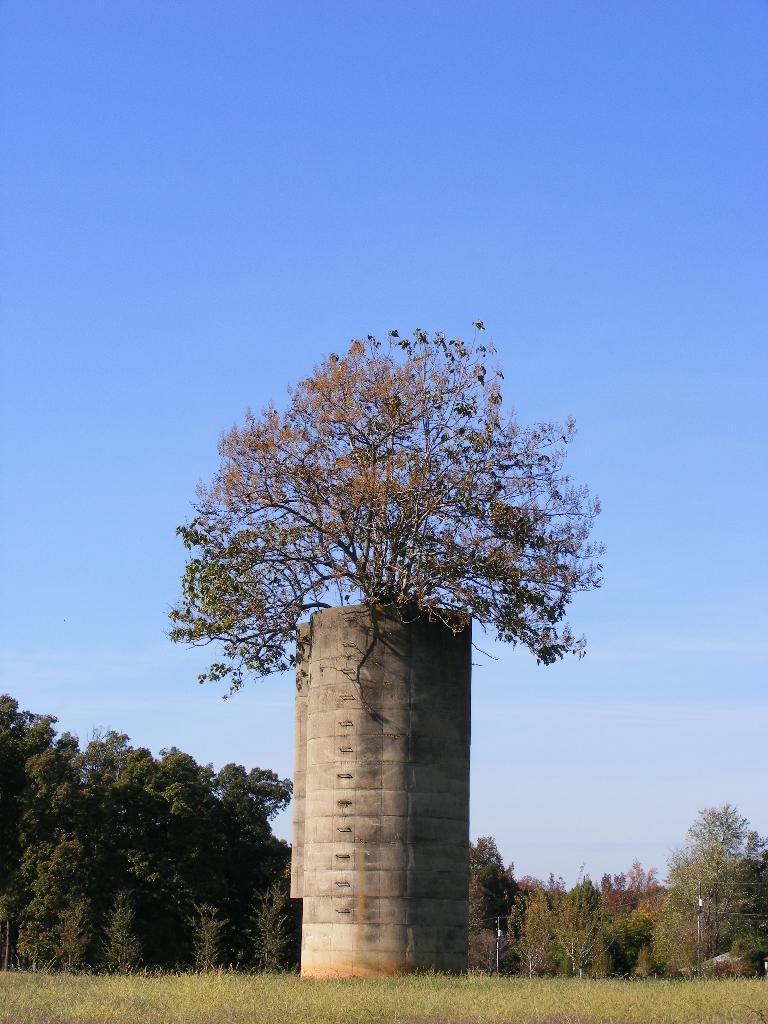How would you summarize this image in a sentence or two? There are trees on a tower which is on the grass on the ground. In the background, there are trees and there are clouds in the blue sky. 